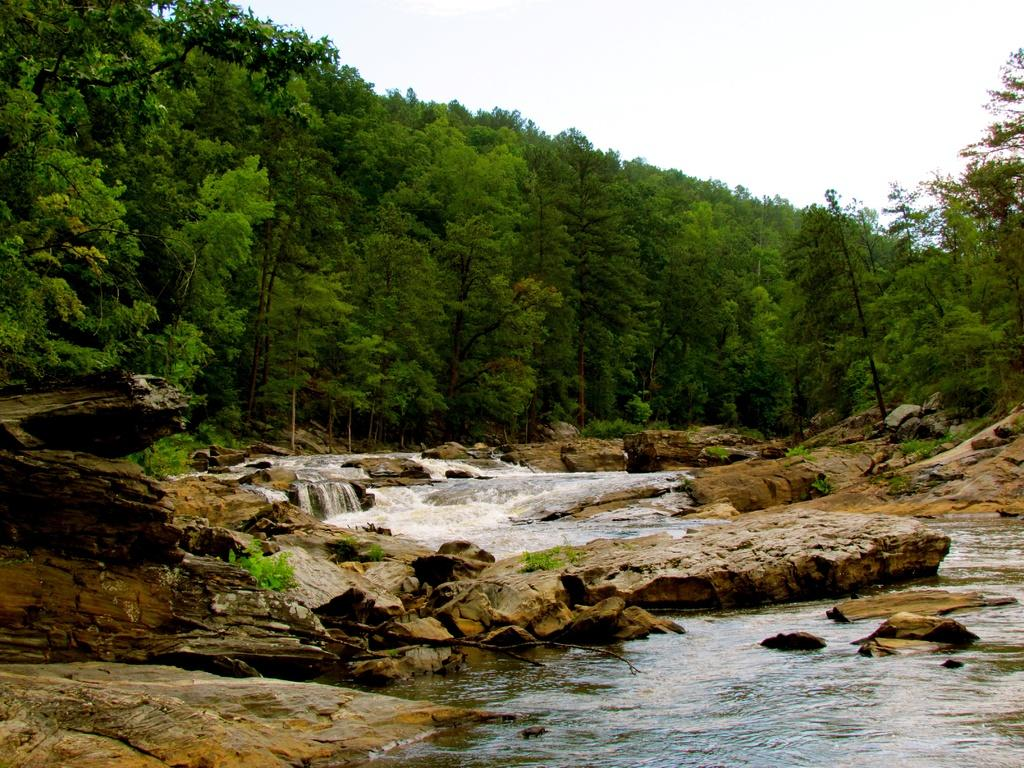What type of natural feature is depicted in the image? There is a river in the image. What can be seen on either side of the river? Rocks are present on either side of the river. What is located in the middle of the river? There are many trees in the middle of the river. What is visible in the background of the image? The sky is visible in the background of the image. How much money does the river contain in the image? The image does not depict any money in the river; it is a natural feature with rocks and trees. 